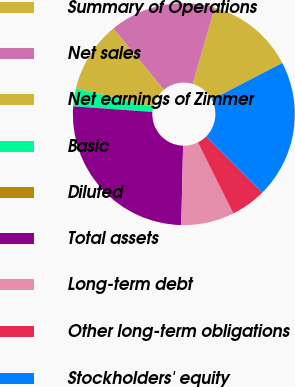Convert chart to OTSL. <chart><loc_0><loc_0><loc_500><loc_500><pie_chart><fcel>Summary of Operations<fcel>Net sales<fcel>Net earnings of Zimmer<fcel>Basic<fcel>Diluted<fcel>Total assets<fcel>Long-term debt<fcel>Other long-term obligations<fcel>Stockholders' equity<nl><fcel>12.88%<fcel>15.46%<fcel>10.31%<fcel>2.59%<fcel>0.01%<fcel>25.75%<fcel>7.73%<fcel>5.16%<fcel>20.11%<nl></chart> 